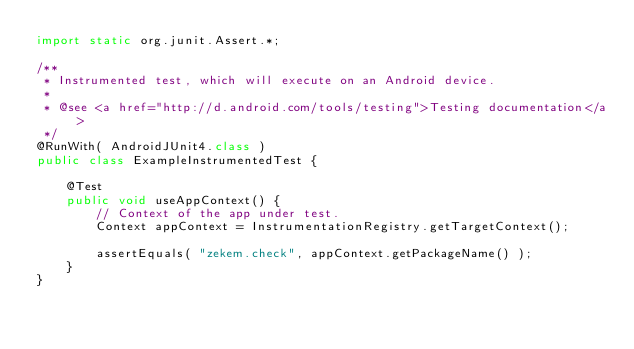Convert code to text. <code><loc_0><loc_0><loc_500><loc_500><_Java_>import static org.junit.Assert.*;

/**
 * Instrumented test, which will execute on an Android device.
 *
 * @see <a href="http://d.android.com/tools/testing">Testing documentation</a>
 */
@RunWith( AndroidJUnit4.class )
public class ExampleInstrumentedTest {

    @Test
    public void useAppContext() {
        // Context of the app under test.
        Context appContext = InstrumentationRegistry.getTargetContext();

        assertEquals( "zekem.check", appContext.getPackageName() );
    }
}
</code> 